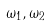Convert formula to latex. <formula><loc_0><loc_0><loc_500><loc_500>\omega _ { 1 } , \omega _ { 2 }</formula> 